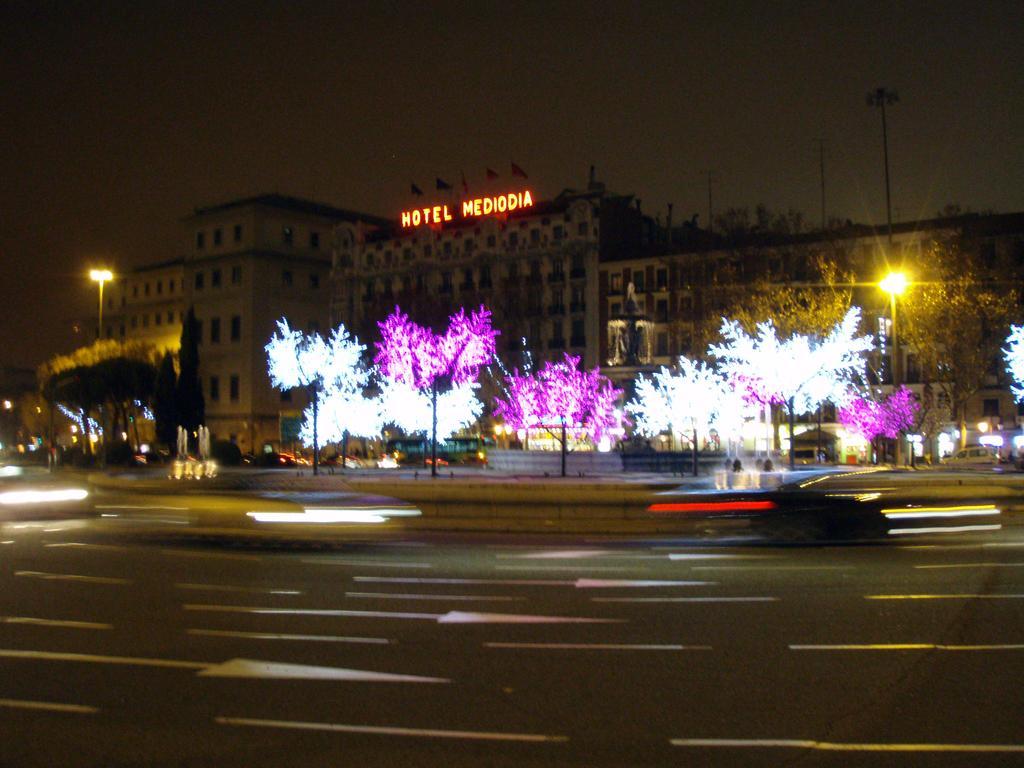In one or two sentences, can you explain what this image depicts? In the picture we can see the road with vehicles and behind it, we can see some trees with lights and behind it, we can see the hotel building and beside it, we can see two poles with lights and behind the building we can see the sky. 